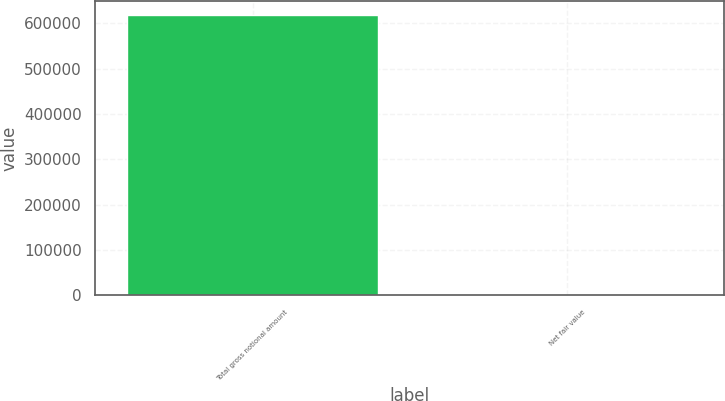<chart> <loc_0><loc_0><loc_500><loc_500><bar_chart><fcel>Total gross notional amount<fcel>Net fair value<nl><fcel>618978<fcel>390<nl></chart> 